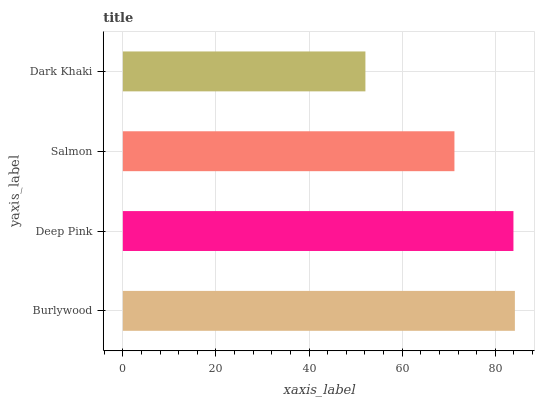Is Dark Khaki the minimum?
Answer yes or no. Yes. Is Burlywood the maximum?
Answer yes or no. Yes. Is Deep Pink the minimum?
Answer yes or no. No. Is Deep Pink the maximum?
Answer yes or no. No. Is Burlywood greater than Deep Pink?
Answer yes or no. Yes. Is Deep Pink less than Burlywood?
Answer yes or no. Yes. Is Deep Pink greater than Burlywood?
Answer yes or no. No. Is Burlywood less than Deep Pink?
Answer yes or no. No. Is Deep Pink the high median?
Answer yes or no. Yes. Is Salmon the low median?
Answer yes or no. Yes. Is Burlywood the high median?
Answer yes or no. No. Is Deep Pink the low median?
Answer yes or no. No. 